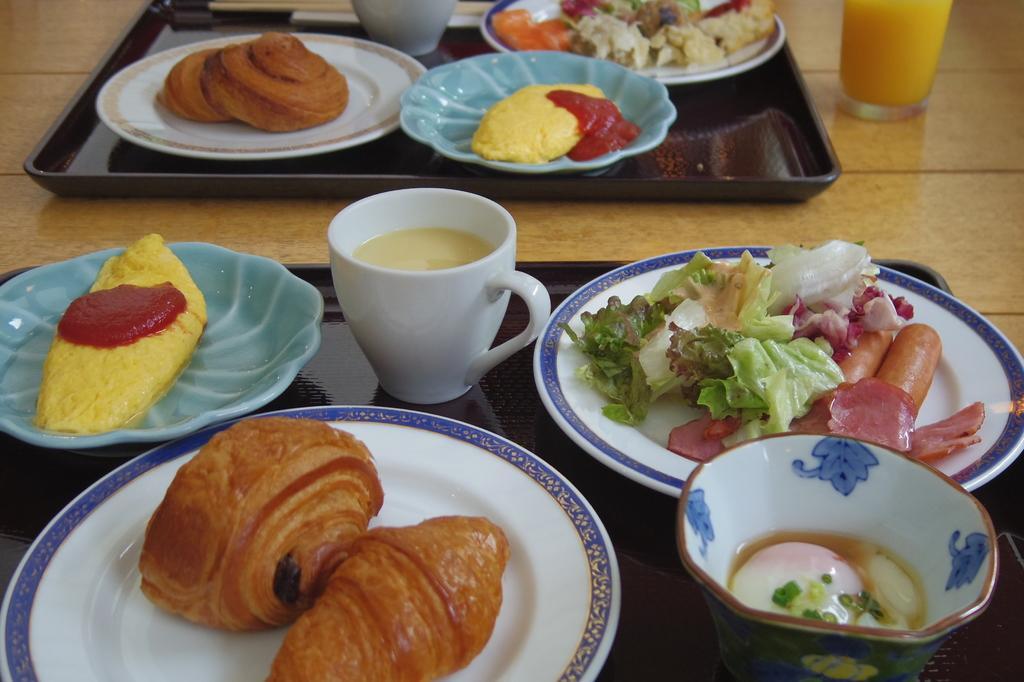Describe this image in one or two sentences. In this image I can see few food items, they are in brown, cream, red, green and orange color and I can see the food items in the plates and the plates are on the tray. I can also see a cup and the tray is on the brown color surface. 